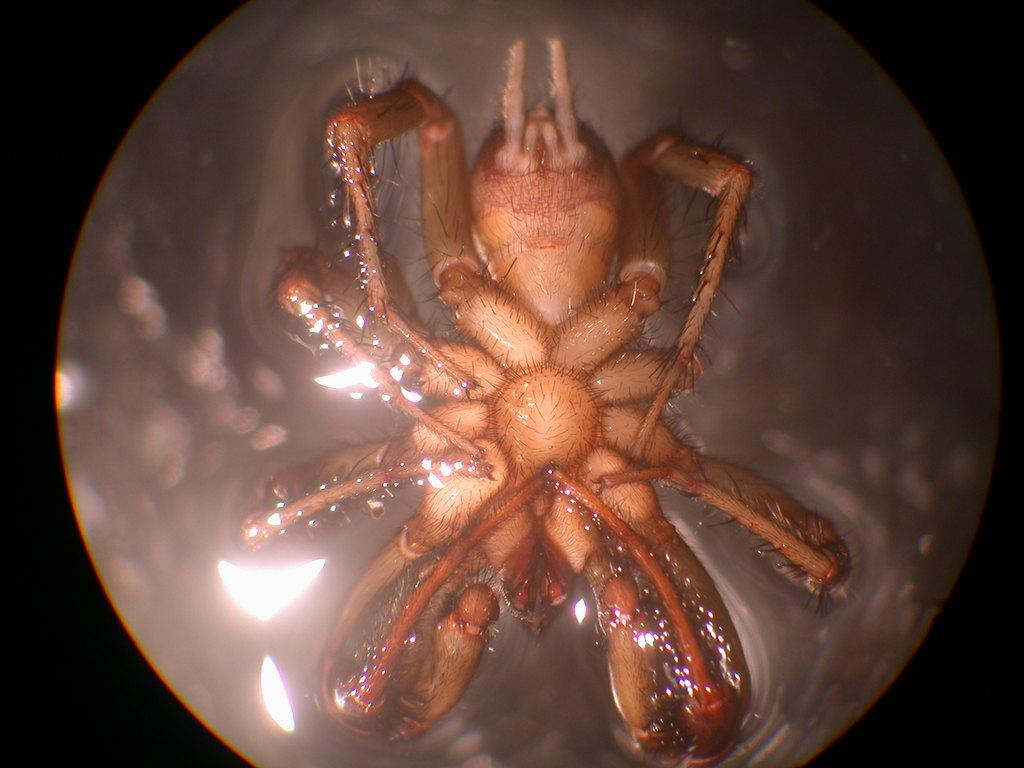What is present in the water in the image? There is a spider in the water in the image. How many geese are flying over the spider in the image? There are no geese present in the image; it only features a spider in the water. 